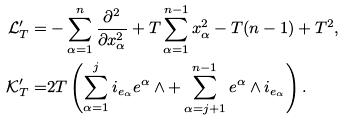<formula> <loc_0><loc_0><loc_500><loc_500>\mathcal { L } ^ { \prime } _ { T } = & - \sum ^ { n } _ { \alpha = 1 } \frac { \partial ^ { 2 } } { \partial x ^ { 2 } _ { \alpha } } + T \sum ^ { n - 1 } _ { \alpha = 1 } x _ { \alpha } ^ { 2 } - T ( n - 1 ) + T ^ { 2 } , \\ \mathcal { K } ^ { \prime } _ { T } = & 2 T \left ( \sum _ { \alpha = 1 } ^ { j } i _ { e _ { \alpha } } { e ^ { \alpha } } \wedge + \sum _ { \alpha = j + 1 } ^ { n - 1 } { e ^ { \alpha } } \wedge i _ { e _ { \alpha } } \right ) .</formula> 